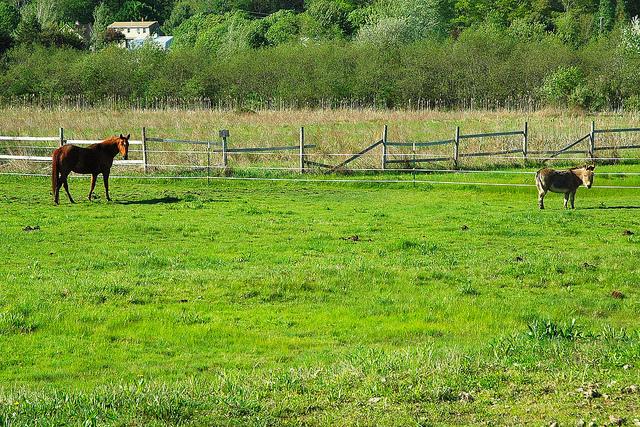Is there grass in the horse's pen?
Concise answer only. Yes. Is all of the grass green?
Keep it brief. Yes. How many animals are in the field?
Be succinct. 2. Is the fence too high for the horses to jump over?
Give a very brief answer. No. Are the animals different?
Quick response, please. Yes. Is the fence broken?
Be succinct. Yes. 